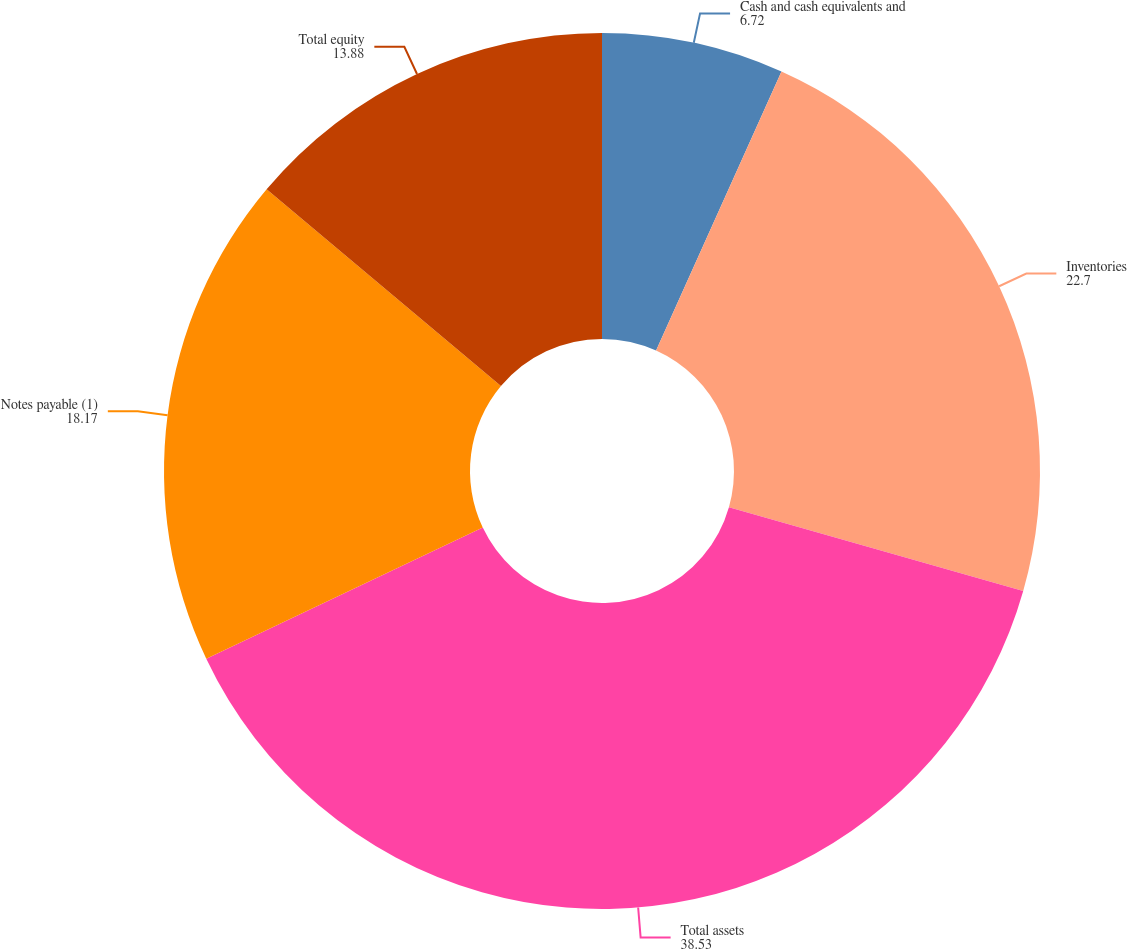Convert chart to OTSL. <chart><loc_0><loc_0><loc_500><loc_500><pie_chart><fcel>Cash and cash equivalents and<fcel>Inventories<fcel>Total assets<fcel>Notes payable (1)<fcel>Total equity<nl><fcel>6.72%<fcel>22.7%<fcel>38.53%<fcel>18.17%<fcel>13.88%<nl></chart> 